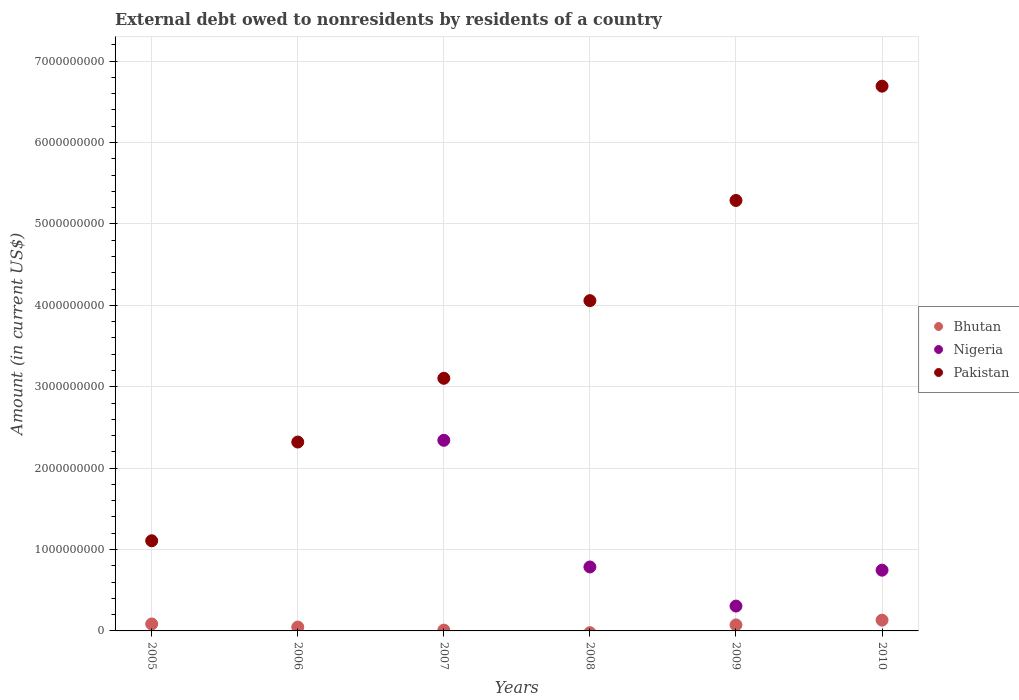How many different coloured dotlines are there?
Your answer should be compact. 3. What is the external debt owed by residents in Nigeria in 2008?
Provide a short and direct response. 7.86e+08. Across all years, what is the maximum external debt owed by residents in Nigeria?
Offer a terse response. 2.34e+09. Across all years, what is the minimum external debt owed by residents in Pakistan?
Provide a short and direct response. 1.11e+09. In which year was the external debt owed by residents in Bhutan maximum?
Make the answer very short. 2010. What is the total external debt owed by residents in Pakistan in the graph?
Your answer should be compact. 2.26e+1. What is the difference between the external debt owed by residents in Nigeria in 2008 and that in 2010?
Your response must be concise. 3.94e+07. What is the difference between the external debt owed by residents in Nigeria in 2010 and the external debt owed by residents in Bhutan in 2007?
Offer a terse response. 7.36e+08. What is the average external debt owed by residents in Pakistan per year?
Give a very brief answer. 3.76e+09. In the year 2009, what is the difference between the external debt owed by residents in Pakistan and external debt owed by residents in Bhutan?
Offer a terse response. 5.21e+09. What is the ratio of the external debt owed by residents in Pakistan in 2006 to that in 2009?
Your response must be concise. 0.44. Is the difference between the external debt owed by residents in Pakistan in 2005 and 2006 greater than the difference between the external debt owed by residents in Bhutan in 2005 and 2006?
Provide a short and direct response. No. What is the difference between the highest and the second highest external debt owed by residents in Nigeria?
Your answer should be very brief. 1.56e+09. What is the difference between the highest and the lowest external debt owed by residents in Bhutan?
Your response must be concise. 1.32e+08. In how many years, is the external debt owed by residents in Nigeria greater than the average external debt owed by residents in Nigeria taken over all years?
Offer a terse response. 3. Is the sum of the external debt owed by residents in Nigeria in 2007 and 2010 greater than the maximum external debt owed by residents in Pakistan across all years?
Your answer should be very brief. No. Is the external debt owed by residents in Pakistan strictly greater than the external debt owed by residents in Bhutan over the years?
Offer a very short reply. Yes. How many dotlines are there?
Ensure brevity in your answer.  3. Are the values on the major ticks of Y-axis written in scientific E-notation?
Provide a short and direct response. No. How many legend labels are there?
Keep it short and to the point. 3. What is the title of the graph?
Offer a terse response. External debt owed to nonresidents by residents of a country. Does "Burkina Faso" appear as one of the legend labels in the graph?
Ensure brevity in your answer.  No. What is the label or title of the Y-axis?
Give a very brief answer. Amount (in current US$). What is the Amount (in current US$) of Bhutan in 2005?
Your response must be concise. 8.53e+07. What is the Amount (in current US$) of Pakistan in 2005?
Ensure brevity in your answer.  1.11e+09. What is the Amount (in current US$) of Bhutan in 2006?
Your answer should be very brief. 4.73e+07. What is the Amount (in current US$) in Pakistan in 2006?
Offer a very short reply. 2.32e+09. What is the Amount (in current US$) in Bhutan in 2007?
Your answer should be compact. 9.97e+06. What is the Amount (in current US$) in Nigeria in 2007?
Give a very brief answer. 2.34e+09. What is the Amount (in current US$) of Pakistan in 2007?
Make the answer very short. 3.10e+09. What is the Amount (in current US$) in Bhutan in 2008?
Keep it short and to the point. 0. What is the Amount (in current US$) of Nigeria in 2008?
Offer a very short reply. 7.86e+08. What is the Amount (in current US$) in Pakistan in 2008?
Provide a succinct answer. 4.06e+09. What is the Amount (in current US$) in Bhutan in 2009?
Your answer should be very brief. 7.39e+07. What is the Amount (in current US$) of Nigeria in 2009?
Your answer should be compact. 3.05e+08. What is the Amount (in current US$) of Pakistan in 2009?
Keep it short and to the point. 5.29e+09. What is the Amount (in current US$) in Bhutan in 2010?
Ensure brevity in your answer.  1.32e+08. What is the Amount (in current US$) in Nigeria in 2010?
Your answer should be very brief. 7.46e+08. What is the Amount (in current US$) in Pakistan in 2010?
Provide a succinct answer. 6.69e+09. Across all years, what is the maximum Amount (in current US$) in Bhutan?
Your answer should be very brief. 1.32e+08. Across all years, what is the maximum Amount (in current US$) of Nigeria?
Make the answer very short. 2.34e+09. Across all years, what is the maximum Amount (in current US$) in Pakistan?
Give a very brief answer. 6.69e+09. Across all years, what is the minimum Amount (in current US$) in Nigeria?
Offer a terse response. 0. Across all years, what is the minimum Amount (in current US$) in Pakistan?
Your response must be concise. 1.11e+09. What is the total Amount (in current US$) of Bhutan in the graph?
Provide a short and direct response. 3.49e+08. What is the total Amount (in current US$) of Nigeria in the graph?
Provide a succinct answer. 4.18e+09. What is the total Amount (in current US$) of Pakistan in the graph?
Offer a very short reply. 2.26e+1. What is the difference between the Amount (in current US$) of Bhutan in 2005 and that in 2006?
Provide a short and direct response. 3.80e+07. What is the difference between the Amount (in current US$) in Pakistan in 2005 and that in 2006?
Your answer should be very brief. -1.21e+09. What is the difference between the Amount (in current US$) of Bhutan in 2005 and that in 2007?
Keep it short and to the point. 7.54e+07. What is the difference between the Amount (in current US$) in Pakistan in 2005 and that in 2007?
Offer a terse response. -2.00e+09. What is the difference between the Amount (in current US$) in Pakistan in 2005 and that in 2008?
Provide a short and direct response. -2.95e+09. What is the difference between the Amount (in current US$) of Bhutan in 2005 and that in 2009?
Your answer should be compact. 1.14e+07. What is the difference between the Amount (in current US$) in Pakistan in 2005 and that in 2009?
Your answer should be compact. -4.18e+09. What is the difference between the Amount (in current US$) of Bhutan in 2005 and that in 2010?
Your answer should be very brief. -4.69e+07. What is the difference between the Amount (in current US$) of Pakistan in 2005 and that in 2010?
Your response must be concise. -5.58e+09. What is the difference between the Amount (in current US$) of Bhutan in 2006 and that in 2007?
Your answer should be very brief. 3.74e+07. What is the difference between the Amount (in current US$) of Pakistan in 2006 and that in 2007?
Offer a terse response. -7.83e+08. What is the difference between the Amount (in current US$) in Pakistan in 2006 and that in 2008?
Offer a very short reply. -1.74e+09. What is the difference between the Amount (in current US$) in Bhutan in 2006 and that in 2009?
Offer a terse response. -2.66e+07. What is the difference between the Amount (in current US$) of Pakistan in 2006 and that in 2009?
Your response must be concise. -2.97e+09. What is the difference between the Amount (in current US$) in Bhutan in 2006 and that in 2010?
Offer a terse response. -8.49e+07. What is the difference between the Amount (in current US$) of Pakistan in 2006 and that in 2010?
Your answer should be very brief. -4.37e+09. What is the difference between the Amount (in current US$) in Nigeria in 2007 and that in 2008?
Your answer should be compact. 1.56e+09. What is the difference between the Amount (in current US$) of Pakistan in 2007 and that in 2008?
Make the answer very short. -9.54e+08. What is the difference between the Amount (in current US$) of Bhutan in 2007 and that in 2009?
Your answer should be compact. -6.40e+07. What is the difference between the Amount (in current US$) of Nigeria in 2007 and that in 2009?
Ensure brevity in your answer.  2.04e+09. What is the difference between the Amount (in current US$) in Pakistan in 2007 and that in 2009?
Your answer should be compact. -2.18e+09. What is the difference between the Amount (in current US$) of Bhutan in 2007 and that in 2010?
Offer a terse response. -1.22e+08. What is the difference between the Amount (in current US$) in Nigeria in 2007 and that in 2010?
Your answer should be very brief. 1.60e+09. What is the difference between the Amount (in current US$) of Pakistan in 2007 and that in 2010?
Your answer should be compact. -3.59e+09. What is the difference between the Amount (in current US$) in Nigeria in 2008 and that in 2009?
Provide a short and direct response. 4.80e+08. What is the difference between the Amount (in current US$) in Pakistan in 2008 and that in 2009?
Give a very brief answer. -1.23e+09. What is the difference between the Amount (in current US$) of Nigeria in 2008 and that in 2010?
Keep it short and to the point. 3.94e+07. What is the difference between the Amount (in current US$) of Pakistan in 2008 and that in 2010?
Offer a very short reply. -2.63e+09. What is the difference between the Amount (in current US$) in Bhutan in 2009 and that in 2010?
Ensure brevity in your answer.  -5.83e+07. What is the difference between the Amount (in current US$) in Nigeria in 2009 and that in 2010?
Your response must be concise. -4.41e+08. What is the difference between the Amount (in current US$) in Pakistan in 2009 and that in 2010?
Keep it short and to the point. -1.40e+09. What is the difference between the Amount (in current US$) in Bhutan in 2005 and the Amount (in current US$) in Pakistan in 2006?
Ensure brevity in your answer.  -2.24e+09. What is the difference between the Amount (in current US$) in Bhutan in 2005 and the Amount (in current US$) in Nigeria in 2007?
Ensure brevity in your answer.  -2.26e+09. What is the difference between the Amount (in current US$) in Bhutan in 2005 and the Amount (in current US$) in Pakistan in 2007?
Make the answer very short. -3.02e+09. What is the difference between the Amount (in current US$) of Bhutan in 2005 and the Amount (in current US$) of Nigeria in 2008?
Make the answer very short. -7.00e+08. What is the difference between the Amount (in current US$) in Bhutan in 2005 and the Amount (in current US$) in Pakistan in 2008?
Your response must be concise. -3.97e+09. What is the difference between the Amount (in current US$) in Bhutan in 2005 and the Amount (in current US$) in Nigeria in 2009?
Give a very brief answer. -2.20e+08. What is the difference between the Amount (in current US$) of Bhutan in 2005 and the Amount (in current US$) of Pakistan in 2009?
Offer a terse response. -5.20e+09. What is the difference between the Amount (in current US$) in Bhutan in 2005 and the Amount (in current US$) in Nigeria in 2010?
Offer a very short reply. -6.61e+08. What is the difference between the Amount (in current US$) in Bhutan in 2005 and the Amount (in current US$) in Pakistan in 2010?
Your response must be concise. -6.61e+09. What is the difference between the Amount (in current US$) of Bhutan in 2006 and the Amount (in current US$) of Nigeria in 2007?
Offer a very short reply. -2.29e+09. What is the difference between the Amount (in current US$) in Bhutan in 2006 and the Amount (in current US$) in Pakistan in 2007?
Your answer should be compact. -3.06e+09. What is the difference between the Amount (in current US$) of Bhutan in 2006 and the Amount (in current US$) of Nigeria in 2008?
Your answer should be compact. -7.38e+08. What is the difference between the Amount (in current US$) of Bhutan in 2006 and the Amount (in current US$) of Pakistan in 2008?
Your response must be concise. -4.01e+09. What is the difference between the Amount (in current US$) in Bhutan in 2006 and the Amount (in current US$) in Nigeria in 2009?
Your answer should be compact. -2.58e+08. What is the difference between the Amount (in current US$) of Bhutan in 2006 and the Amount (in current US$) of Pakistan in 2009?
Give a very brief answer. -5.24e+09. What is the difference between the Amount (in current US$) of Bhutan in 2006 and the Amount (in current US$) of Nigeria in 2010?
Your answer should be compact. -6.99e+08. What is the difference between the Amount (in current US$) of Bhutan in 2006 and the Amount (in current US$) of Pakistan in 2010?
Ensure brevity in your answer.  -6.65e+09. What is the difference between the Amount (in current US$) of Bhutan in 2007 and the Amount (in current US$) of Nigeria in 2008?
Offer a very short reply. -7.76e+08. What is the difference between the Amount (in current US$) of Bhutan in 2007 and the Amount (in current US$) of Pakistan in 2008?
Your answer should be compact. -4.05e+09. What is the difference between the Amount (in current US$) of Nigeria in 2007 and the Amount (in current US$) of Pakistan in 2008?
Your answer should be compact. -1.72e+09. What is the difference between the Amount (in current US$) of Bhutan in 2007 and the Amount (in current US$) of Nigeria in 2009?
Offer a terse response. -2.95e+08. What is the difference between the Amount (in current US$) of Bhutan in 2007 and the Amount (in current US$) of Pakistan in 2009?
Ensure brevity in your answer.  -5.28e+09. What is the difference between the Amount (in current US$) in Nigeria in 2007 and the Amount (in current US$) in Pakistan in 2009?
Provide a succinct answer. -2.95e+09. What is the difference between the Amount (in current US$) of Bhutan in 2007 and the Amount (in current US$) of Nigeria in 2010?
Keep it short and to the point. -7.36e+08. What is the difference between the Amount (in current US$) in Bhutan in 2007 and the Amount (in current US$) in Pakistan in 2010?
Your answer should be compact. -6.68e+09. What is the difference between the Amount (in current US$) of Nigeria in 2007 and the Amount (in current US$) of Pakistan in 2010?
Make the answer very short. -4.35e+09. What is the difference between the Amount (in current US$) in Nigeria in 2008 and the Amount (in current US$) in Pakistan in 2009?
Ensure brevity in your answer.  -4.50e+09. What is the difference between the Amount (in current US$) in Nigeria in 2008 and the Amount (in current US$) in Pakistan in 2010?
Your answer should be very brief. -5.91e+09. What is the difference between the Amount (in current US$) of Bhutan in 2009 and the Amount (in current US$) of Nigeria in 2010?
Provide a short and direct response. -6.72e+08. What is the difference between the Amount (in current US$) in Bhutan in 2009 and the Amount (in current US$) in Pakistan in 2010?
Provide a short and direct response. -6.62e+09. What is the difference between the Amount (in current US$) in Nigeria in 2009 and the Amount (in current US$) in Pakistan in 2010?
Your answer should be very brief. -6.39e+09. What is the average Amount (in current US$) in Bhutan per year?
Give a very brief answer. 5.81e+07. What is the average Amount (in current US$) of Nigeria per year?
Your response must be concise. 6.97e+08. What is the average Amount (in current US$) in Pakistan per year?
Your answer should be very brief. 3.76e+09. In the year 2005, what is the difference between the Amount (in current US$) of Bhutan and Amount (in current US$) of Pakistan?
Make the answer very short. -1.02e+09. In the year 2006, what is the difference between the Amount (in current US$) in Bhutan and Amount (in current US$) in Pakistan?
Make the answer very short. -2.27e+09. In the year 2007, what is the difference between the Amount (in current US$) of Bhutan and Amount (in current US$) of Nigeria?
Offer a terse response. -2.33e+09. In the year 2007, what is the difference between the Amount (in current US$) of Bhutan and Amount (in current US$) of Pakistan?
Provide a short and direct response. -3.09e+09. In the year 2007, what is the difference between the Amount (in current US$) of Nigeria and Amount (in current US$) of Pakistan?
Ensure brevity in your answer.  -7.62e+08. In the year 2008, what is the difference between the Amount (in current US$) of Nigeria and Amount (in current US$) of Pakistan?
Your answer should be very brief. -3.27e+09. In the year 2009, what is the difference between the Amount (in current US$) of Bhutan and Amount (in current US$) of Nigeria?
Ensure brevity in your answer.  -2.32e+08. In the year 2009, what is the difference between the Amount (in current US$) of Bhutan and Amount (in current US$) of Pakistan?
Your answer should be compact. -5.21e+09. In the year 2009, what is the difference between the Amount (in current US$) of Nigeria and Amount (in current US$) of Pakistan?
Offer a very short reply. -4.98e+09. In the year 2010, what is the difference between the Amount (in current US$) of Bhutan and Amount (in current US$) of Nigeria?
Offer a very short reply. -6.14e+08. In the year 2010, what is the difference between the Amount (in current US$) in Bhutan and Amount (in current US$) in Pakistan?
Your answer should be compact. -6.56e+09. In the year 2010, what is the difference between the Amount (in current US$) in Nigeria and Amount (in current US$) in Pakistan?
Make the answer very short. -5.95e+09. What is the ratio of the Amount (in current US$) of Bhutan in 2005 to that in 2006?
Your answer should be compact. 1.8. What is the ratio of the Amount (in current US$) in Pakistan in 2005 to that in 2006?
Your answer should be very brief. 0.48. What is the ratio of the Amount (in current US$) of Bhutan in 2005 to that in 2007?
Offer a very short reply. 8.56. What is the ratio of the Amount (in current US$) of Pakistan in 2005 to that in 2007?
Make the answer very short. 0.36. What is the ratio of the Amount (in current US$) in Pakistan in 2005 to that in 2008?
Provide a short and direct response. 0.27. What is the ratio of the Amount (in current US$) of Bhutan in 2005 to that in 2009?
Offer a very short reply. 1.15. What is the ratio of the Amount (in current US$) of Pakistan in 2005 to that in 2009?
Your answer should be very brief. 0.21. What is the ratio of the Amount (in current US$) of Bhutan in 2005 to that in 2010?
Provide a short and direct response. 0.65. What is the ratio of the Amount (in current US$) in Pakistan in 2005 to that in 2010?
Give a very brief answer. 0.17. What is the ratio of the Amount (in current US$) of Bhutan in 2006 to that in 2007?
Give a very brief answer. 4.75. What is the ratio of the Amount (in current US$) in Pakistan in 2006 to that in 2007?
Your answer should be very brief. 0.75. What is the ratio of the Amount (in current US$) of Pakistan in 2006 to that in 2008?
Offer a very short reply. 0.57. What is the ratio of the Amount (in current US$) in Bhutan in 2006 to that in 2009?
Your answer should be compact. 0.64. What is the ratio of the Amount (in current US$) of Pakistan in 2006 to that in 2009?
Make the answer very short. 0.44. What is the ratio of the Amount (in current US$) of Bhutan in 2006 to that in 2010?
Provide a succinct answer. 0.36. What is the ratio of the Amount (in current US$) in Pakistan in 2006 to that in 2010?
Keep it short and to the point. 0.35. What is the ratio of the Amount (in current US$) in Nigeria in 2007 to that in 2008?
Ensure brevity in your answer.  2.98. What is the ratio of the Amount (in current US$) in Pakistan in 2007 to that in 2008?
Ensure brevity in your answer.  0.76. What is the ratio of the Amount (in current US$) in Bhutan in 2007 to that in 2009?
Ensure brevity in your answer.  0.13. What is the ratio of the Amount (in current US$) of Nigeria in 2007 to that in 2009?
Offer a very short reply. 7.67. What is the ratio of the Amount (in current US$) in Pakistan in 2007 to that in 2009?
Your response must be concise. 0.59. What is the ratio of the Amount (in current US$) of Bhutan in 2007 to that in 2010?
Provide a succinct answer. 0.08. What is the ratio of the Amount (in current US$) in Nigeria in 2007 to that in 2010?
Your response must be concise. 3.14. What is the ratio of the Amount (in current US$) in Pakistan in 2007 to that in 2010?
Ensure brevity in your answer.  0.46. What is the ratio of the Amount (in current US$) of Nigeria in 2008 to that in 2009?
Keep it short and to the point. 2.57. What is the ratio of the Amount (in current US$) of Pakistan in 2008 to that in 2009?
Provide a short and direct response. 0.77. What is the ratio of the Amount (in current US$) in Nigeria in 2008 to that in 2010?
Your answer should be very brief. 1.05. What is the ratio of the Amount (in current US$) of Pakistan in 2008 to that in 2010?
Offer a terse response. 0.61. What is the ratio of the Amount (in current US$) of Bhutan in 2009 to that in 2010?
Offer a very short reply. 0.56. What is the ratio of the Amount (in current US$) of Nigeria in 2009 to that in 2010?
Your answer should be very brief. 0.41. What is the ratio of the Amount (in current US$) in Pakistan in 2009 to that in 2010?
Offer a terse response. 0.79. What is the difference between the highest and the second highest Amount (in current US$) of Bhutan?
Provide a short and direct response. 4.69e+07. What is the difference between the highest and the second highest Amount (in current US$) of Nigeria?
Make the answer very short. 1.56e+09. What is the difference between the highest and the second highest Amount (in current US$) of Pakistan?
Your answer should be very brief. 1.40e+09. What is the difference between the highest and the lowest Amount (in current US$) in Bhutan?
Provide a short and direct response. 1.32e+08. What is the difference between the highest and the lowest Amount (in current US$) of Nigeria?
Provide a succinct answer. 2.34e+09. What is the difference between the highest and the lowest Amount (in current US$) of Pakistan?
Provide a succinct answer. 5.58e+09. 